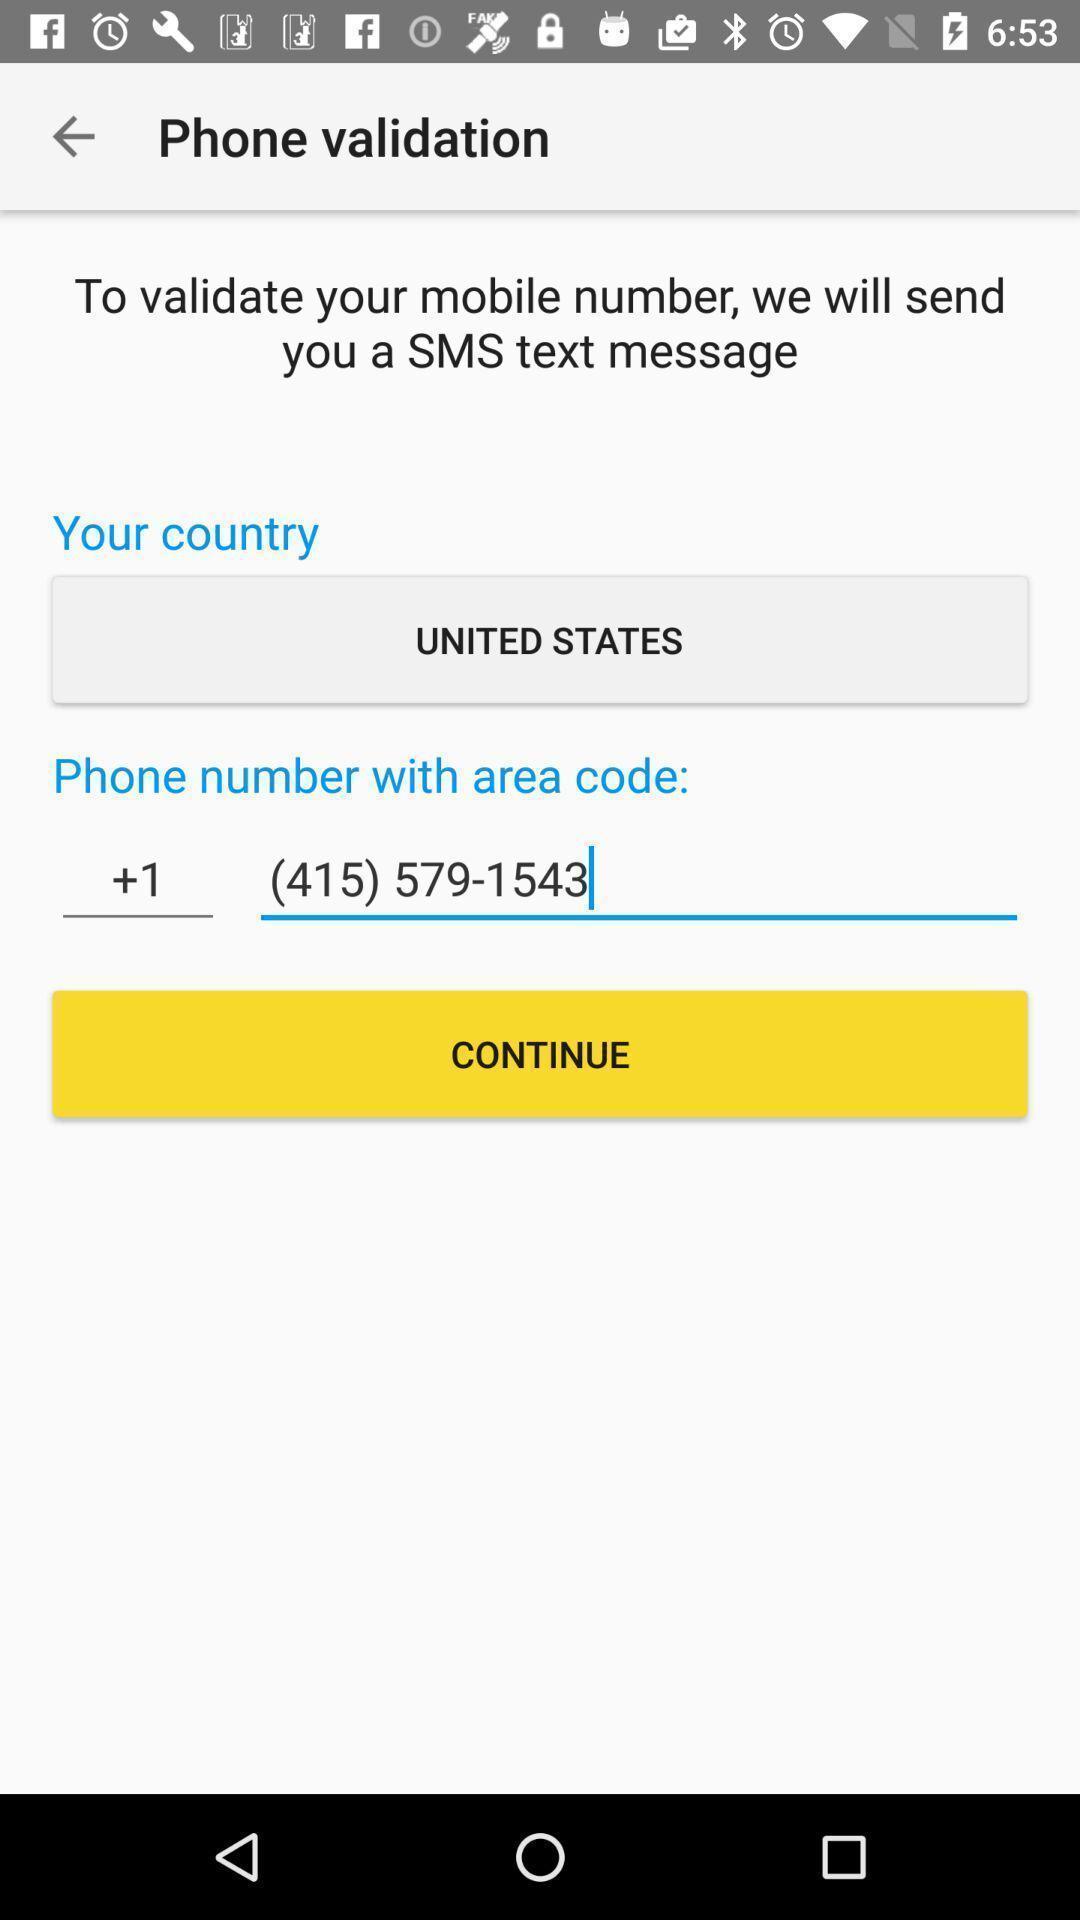Describe the key features of this screenshot. Validation tab in the application to verify the credential. 